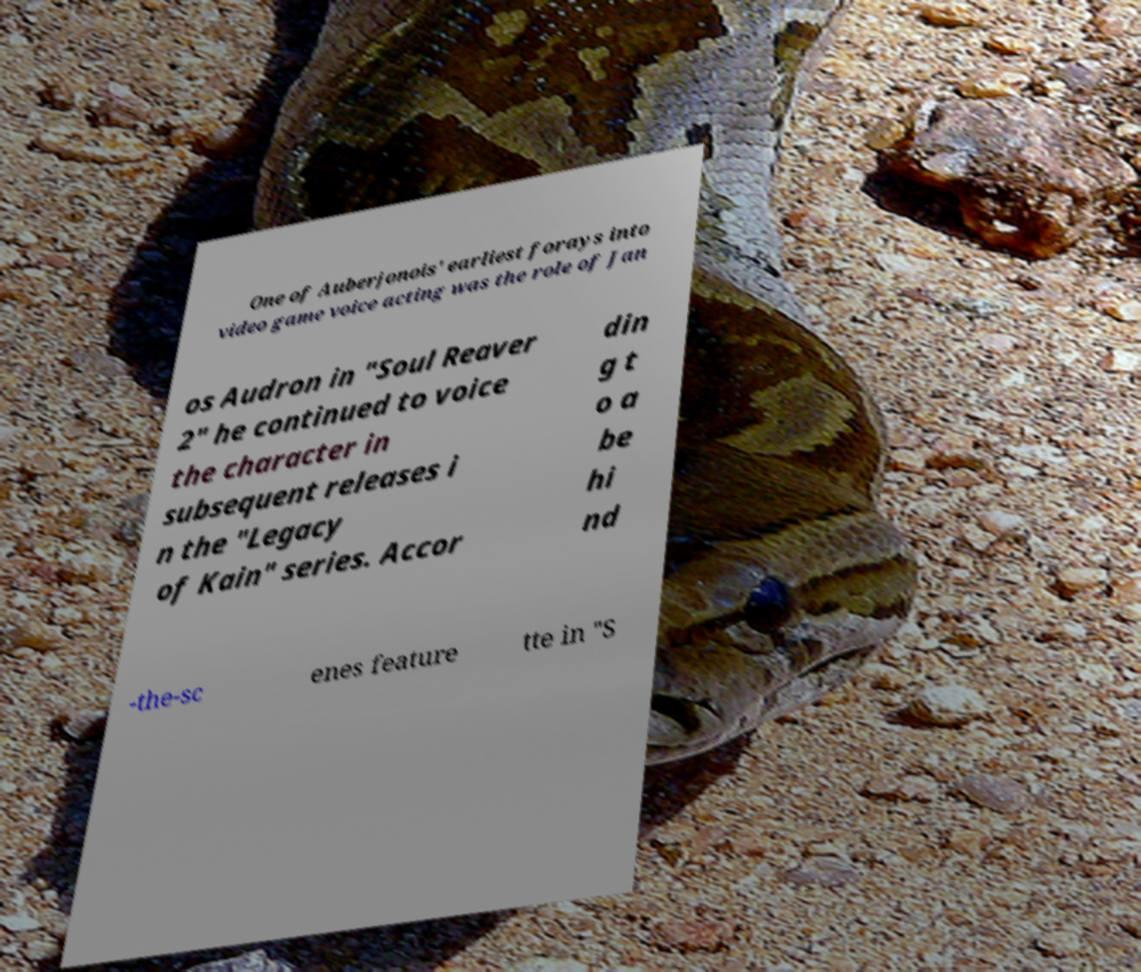Please read and relay the text visible in this image. What does it say? One of Auberjonois' earliest forays into video game voice acting was the role of Jan os Audron in "Soul Reaver 2" he continued to voice the character in subsequent releases i n the "Legacy of Kain" series. Accor din g t o a be hi nd -the-sc enes feature tte in "S 